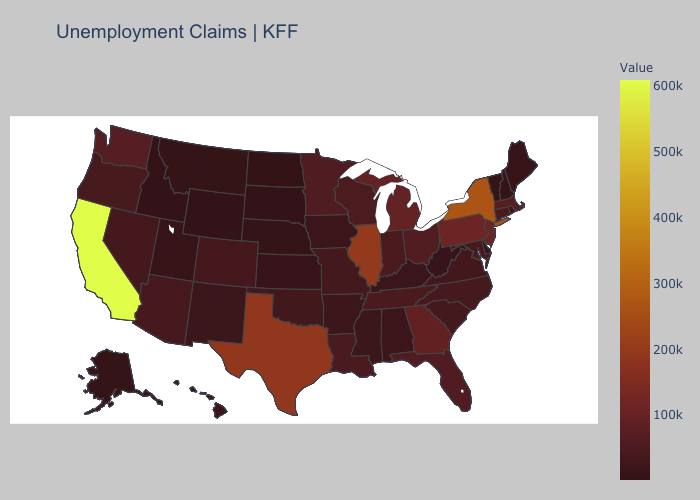Does Idaho have the highest value in the West?
Give a very brief answer. No. Among the states that border Mississippi , which have the lowest value?
Short answer required. Alabama. Does the map have missing data?
Answer briefly. No. Does the map have missing data?
Quick response, please. No. Which states have the highest value in the USA?
Give a very brief answer. California. Among the states that border New York , which have the lowest value?
Concise answer only. Vermont. Among the states that border Vermont , does New Hampshire have the highest value?
Be succinct. No. Does South Dakota have the lowest value in the USA?
Keep it brief. Yes. 